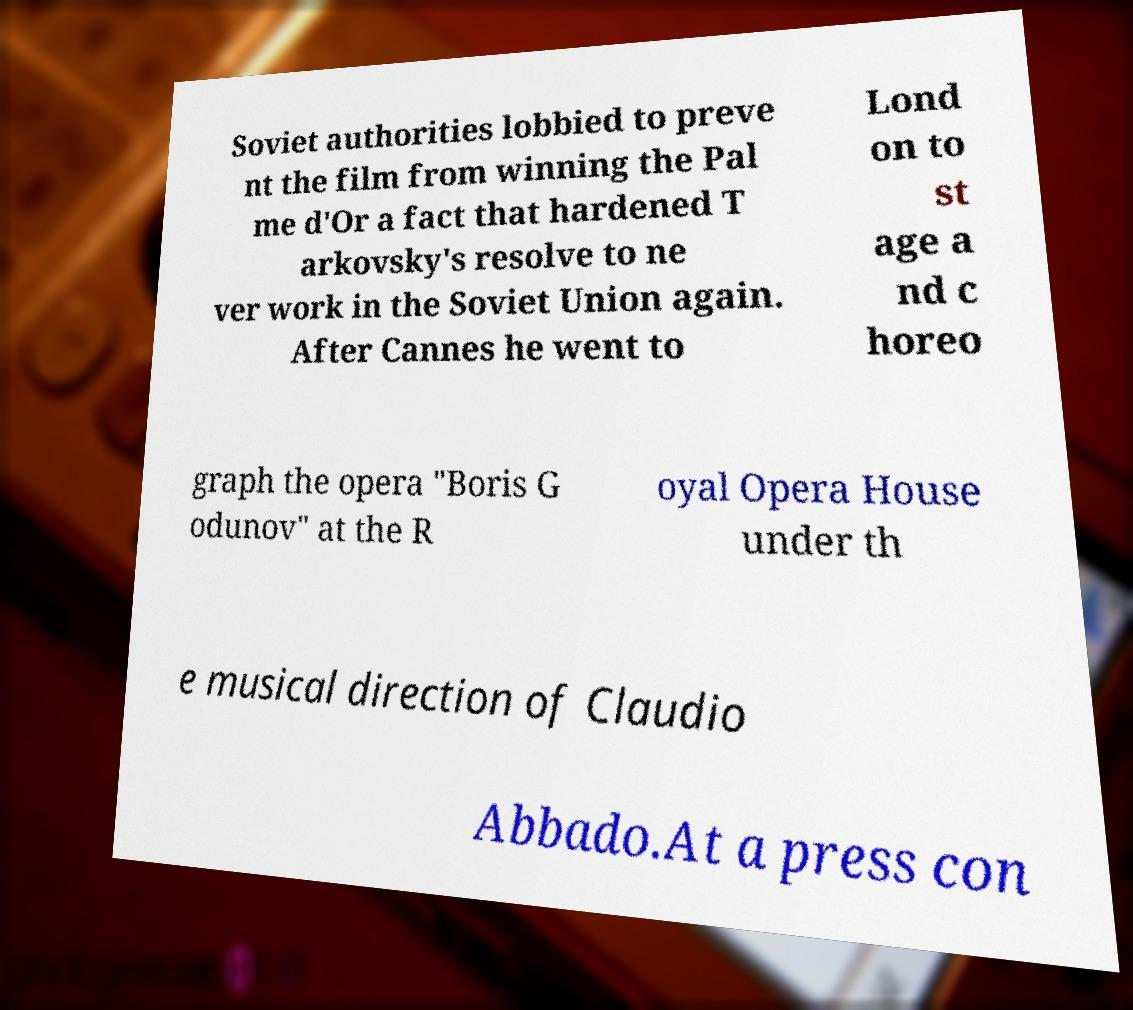What messages or text are displayed in this image? I need them in a readable, typed format. Soviet authorities lobbied to preve nt the film from winning the Pal me d'Or a fact that hardened T arkovsky's resolve to ne ver work in the Soviet Union again. After Cannes he went to Lond on to st age a nd c horeo graph the opera "Boris G odunov" at the R oyal Opera House under th e musical direction of Claudio Abbado.At a press con 